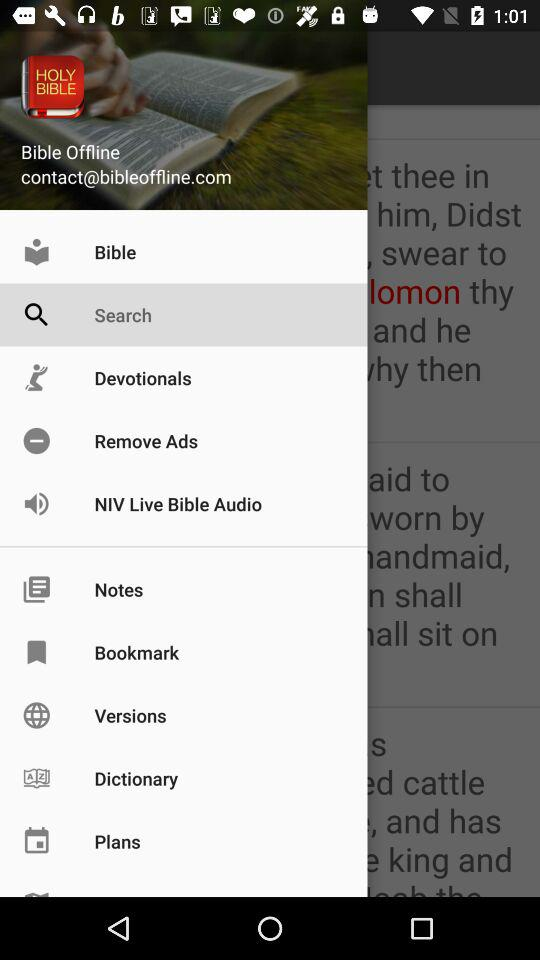What is the email address? The email address is contact@bibleoffline.com. 